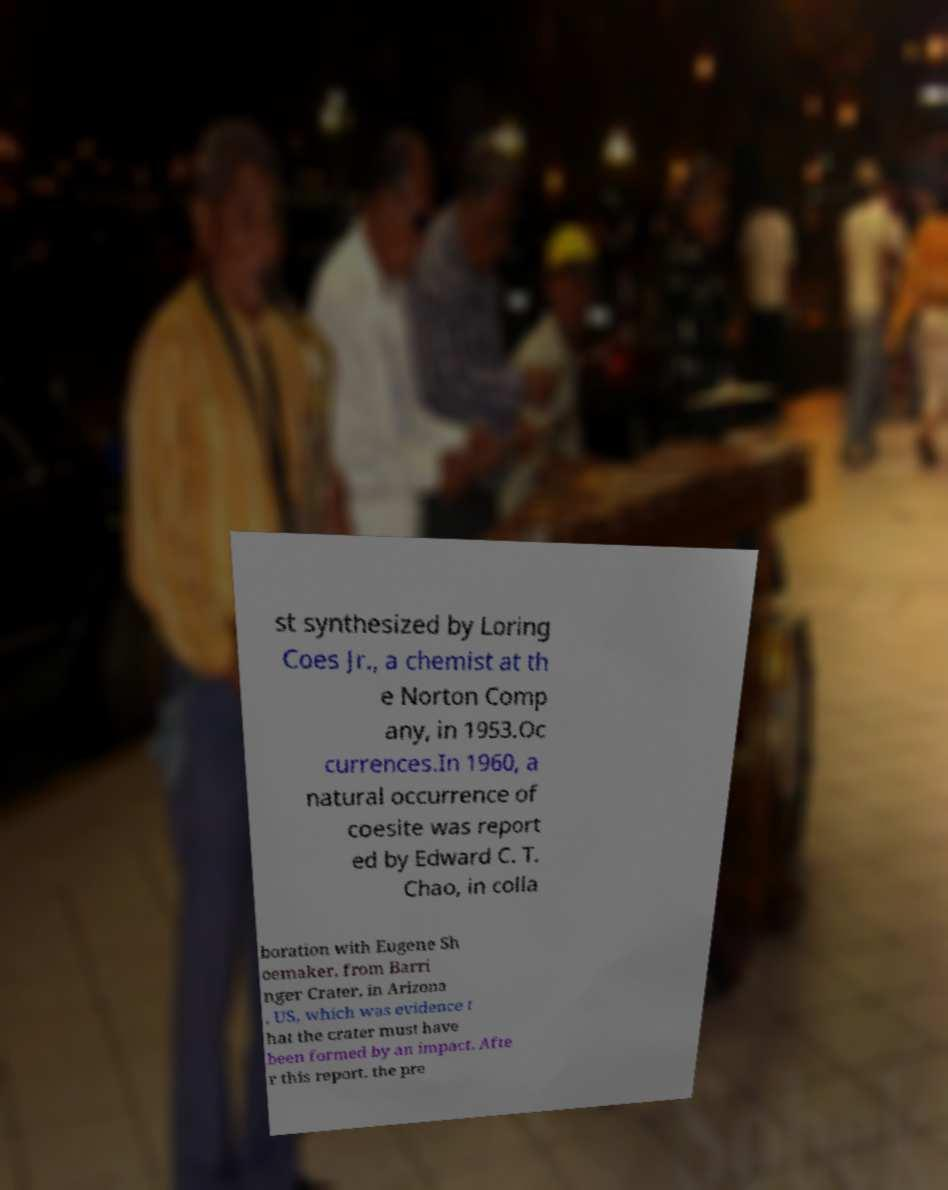Can you accurately transcribe the text from the provided image for me? st synthesized by Loring Coes Jr., a chemist at th e Norton Comp any, in 1953.Oc currences.In 1960, a natural occurrence of coesite was report ed by Edward C. T. Chao, in colla boration with Eugene Sh oemaker, from Barri nger Crater, in Arizona , US, which was evidence t hat the crater must have been formed by an impact. Afte r this report, the pre 